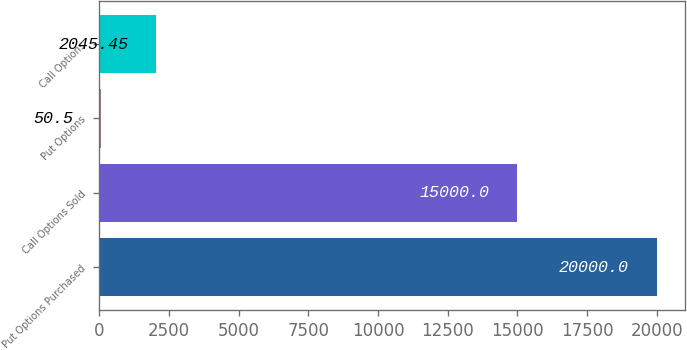Convert chart to OTSL. <chart><loc_0><loc_0><loc_500><loc_500><bar_chart><fcel>Put Options Purchased<fcel>Call Options Sold<fcel>Put Options<fcel>Call Options<nl><fcel>20000<fcel>15000<fcel>50.5<fcel>2045.45<nl></chart> 